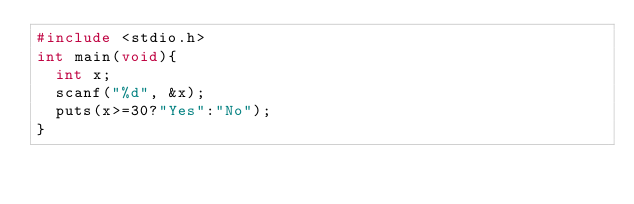Convert code to text. <code><loc_0><loc_0><loc_500><loc_500><_C_>#include <stdio.h>
int main(void){
  int x;
  scanf("%d", &x);
  puts(x>=30?"Yes":"No");
}</code> 